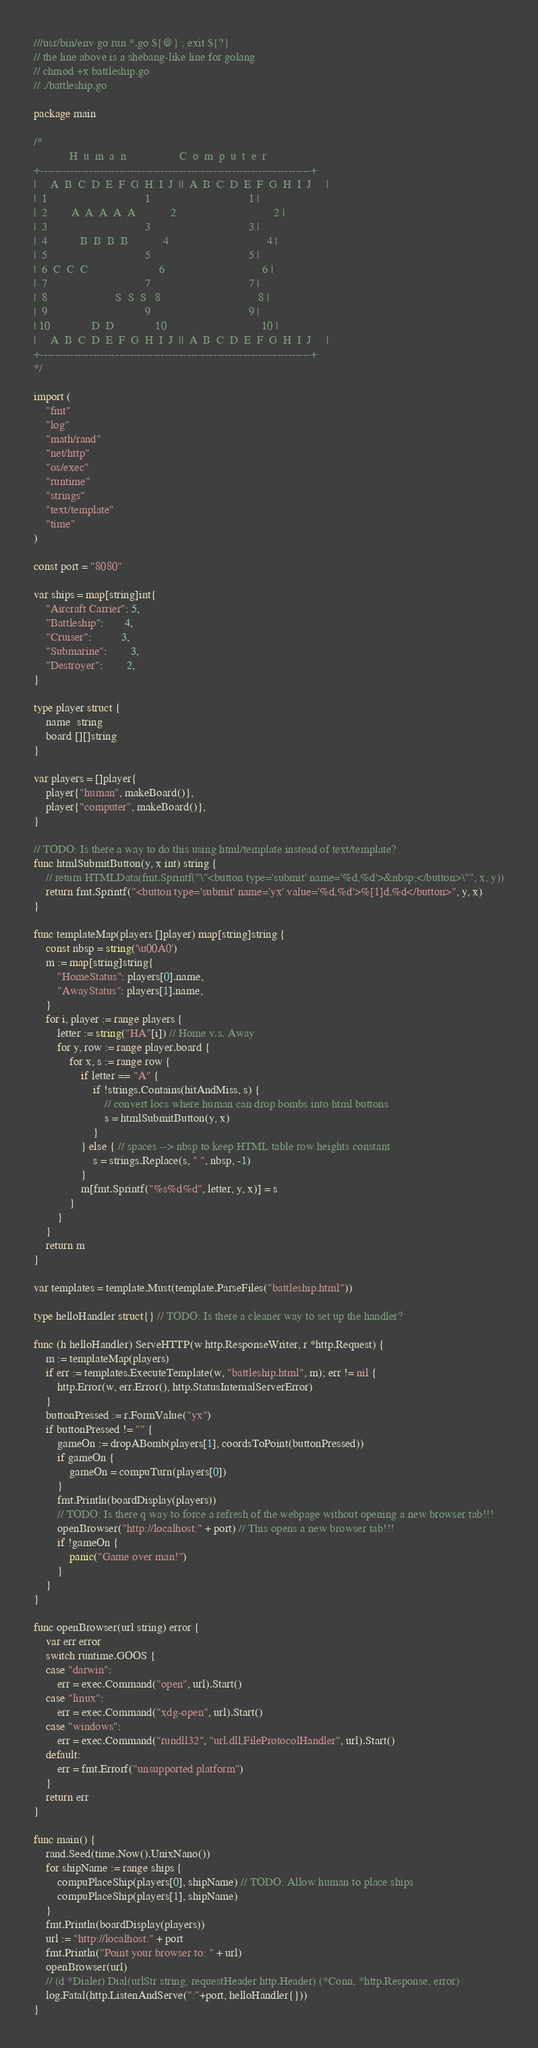<code> <loc_0><loc_0><loc_500><loc_500><_Go_>///usr/bin/env go run *.go ${@} ; exit ${?}
// the line above is a shebang-like line for golang
// chmod +x battleship.go
// ./battleship.go

package main

/*
            H  u  m  a  n                  C  o  m  p  u  t  e  r
+------------------------------------------------------------------------+
|     A  B  C  D  E  F  G  H  I  J  ||  A  B  C  D  E  F  G  H  I  J     |
|  1                                 1                                 1 |
|  2        A  A  A  A  A            2                                 2 |
|  3                                 3                                 3 |
|  4           B  B  B  B            4                                 4 |
|  5                                 5                                 5 |
|  6  C  C  C                        6                                 6 |
|  7                                 7                                 7 |
|  8                       S  S  S   8                                 8 |
|  9                                 9                                 9 |
| 10              D  D              10                                10 |
|     A  B  C  D  E  F  G  H  I  J  ||  A  B  C  D  E  F  G  H  I  J     |
+------------------------------------------------------------------------+
*/

import (
	"fmt"
	"log"
	"math/rand"
	"net/http"
	"os/exec"
	"runtime"
	"strings"
	"text/template"
	"time"
)

const port = "8080"

var ships = map[string]int{
	"Aircraft Carrier": 5,
	"Battleship":       4,
	"Cruiser":          3,
	"Submarine":        3,
	"Destroyer":        2,
}

type player struct {
	name  string
	board [][]string
}

var players = []player{
	player{"human", makeBoard()},
	player{"computer", makeBoard()},
}

// TODO: Is there a way to do this using html/template instead of text/template?
func htmlSubmitButton(y, x int) string {
	// return HTMLData(fmt.Sprintf("\"<button type='submit' name='%d,%d'>&nbsp;</button>\"", x, y))
	return fmt.Sprintf("<button type='submit' name='yx' value='%d,%d'>%[1]d,%d</button>", y, x)
}

func templateMap(players []player) map[string]string {
	const nbsp = string('\u00A0')
	m := map[string]string{
		"HomeStatus": players[0].name,
		"AwayStatus": players[1].name,
	}
	for i, player := range players {
		letter := string("HA"[i]) // Home v.s. Away
		for y, row := range player.board {
			for x, s := range row {
				if letter == "A" {
					if !strings.Contains(hitAndMiss, s) {
						// convert locs where human can drop bombs into html buttons
						s = htmlSubmitButton(y, x)
					}
				} else { // spaces --> nbsp to keep HTML table row heights constant
					s = strings.Replace(s, " ", nbsp, -1)
				}
				m[fmt.Sprintf("%s%d%d", letter, y, x)] = s
			}
		}
	}
	return m
}

var templates = template.Must(template.ParseFiles("battleship.html"))

type helloHandler struct{} // TODO: Is there a cleaner way to set up the handler?

func (h helloHandler) ServeHTTP(w http.ResponseWriter, r *http.Request) {
	m := templateMap(players)
	if err := templates.ExecuteTemplate(w, "battleship.html", m); err != nil {
		http.Error(w, err.Error(), http.StatusInternalServerError)
	}
	buttonPressed := r.FormValue("yx")
	if buttonPressed != "" {
		gameOn := dropABomb(players[1], coordsToPoint(buttonPressed))
		if gameOn {
			gameOn = compuTurn(players[0])
		}
		fmt.Println(boardDisplay(players))
		// TODO: Is there q way to force a refresh of the webpage without opening a new browser tab!!!
		openBrowser("http://localhost:" + port) // This opens a new browser tab!!!
		if !gameOn {
			panic("Game over man!")
		}
	}
}

func openBrowser(url string) error {
	var err error
	switch runtime.GOOS {
	case "darwin":
		err = exec.Command("open", url).Start()
	case "linux":
		err = exec.Command("xdg-open", url).Start()
	case "windows":
		err = exec.Command("rundll32", "url.dll,FileProtocolHandler", url).Start()
	default:
		err = fmt.Errorf("unsupported platform")
	}
	return err
}

func main() {
	rand.Seed(time.Now().UnixNano())
	for shipName := range ships {
		compuPlaceShip(players[0], shipName) // TODO: Allow human to place ships
		compuPlaceShip(players[1], shipName)
	}
	fmt.Println(boardDisplay(players))
	url := "http://localhost:" + port
	fmt.Println("Point your browser to: " + url)
	openBrowser(url)
	// (d *Dialer) Dial(urlStr string, requestHeader http.Header) (*Conn, *http.Response, error)
	log.Fatal(http.ListenAndServe(":"+port, helloHandler{}))
}
</code> 